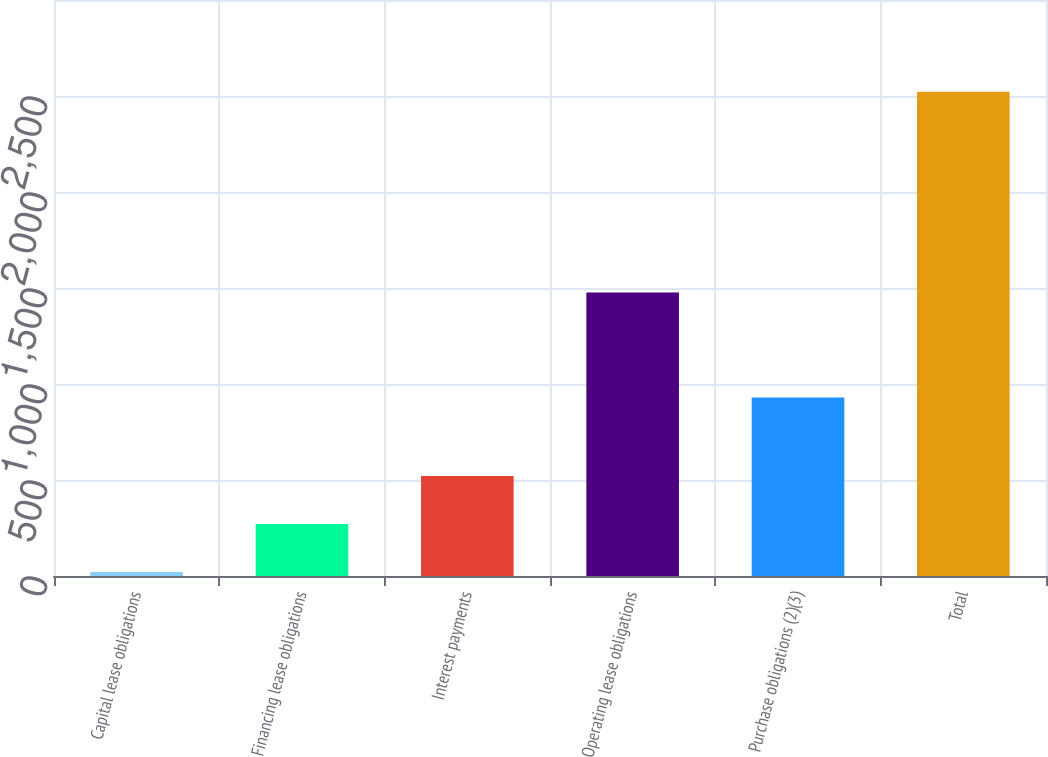<chart> <loc_0><loc_0><loc_500><loc_500><bar_chart><fcel>Capital lease obligations<fcel>Financing lease obligations<fcel>Interest payments<fcel>Operating lease obligations<fcel>Purchase obligations (2)(3)<fcel>Total<nl><fcel>21<fcel>271.1<fcel>521.2<fcel>1477<fcel>930<fcel>2522<nl></chart> 